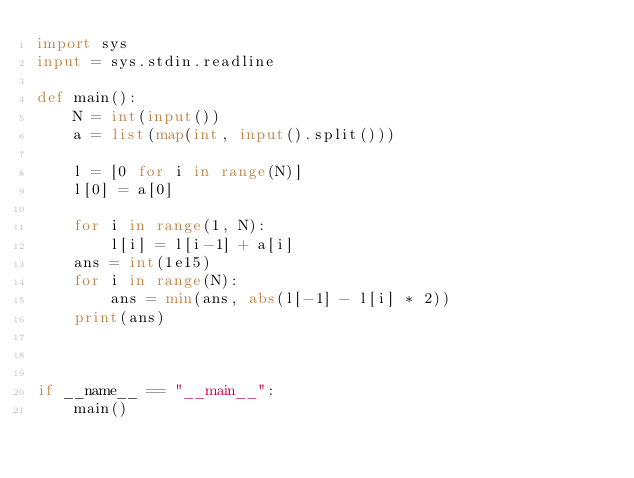<code> <loc_0><loc_0><loc_500><loc_500><_Python_>import sys
input = sys.stdin.readline

def main():
    N = int(input())
    a = list(map(int, input().split()))

    l = [0 for i in range(N)]
    l[0] = a[0]

    for i in range(1, N):
        l[i] = l[i-1] + a[i]
    ans = int(1e15)
    for i in range(N):
        ans = min(ans, abs(l[-1] - l[i] * 2))
    print(ans)



if __name__ == "__main__":
    main()</code> 